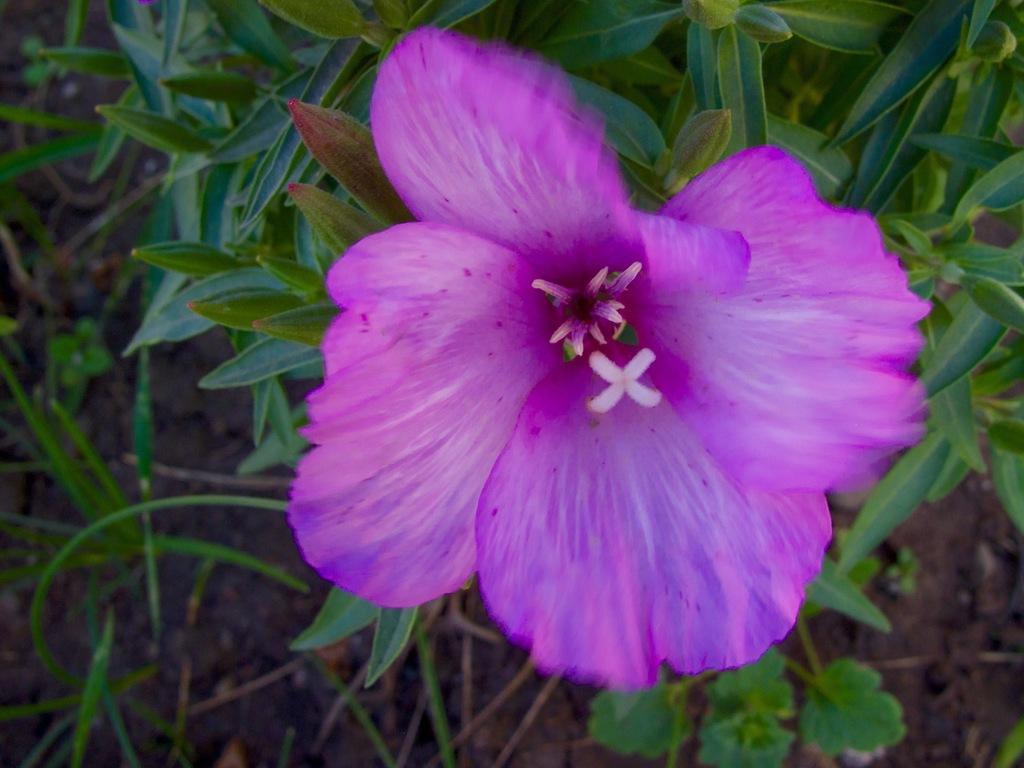How would you summarize this image in a sentence or two? In this picture we can see a purple color flower and some leaves here, we can see petals of the flower. 